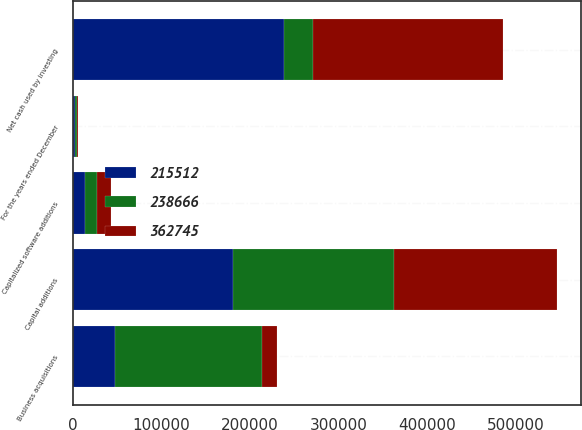Convert chart to OTSL. <chart><loc_0><loc_0><loc_500><loc_500><stacked_bar_chart><ecel><fcel>For the years ended December<fcel>Capital additions<fcel>Capitalized software additions<fcel>Business acquisitions<fcel>Net cash used by investing<nl><fcel>362745<fcel>2006<fcel>183496<fcel>15016<fcel>17000<fcel>215512<nl><fcel>215512<fcel>2005<fcel>181069<fcel>13236<fcel>47074<fcel>238666<nl><fcel>238666<fcel>2004<fcel>181728<fcel>14158<fcel>166859<fcel>32037<nl></chart> 